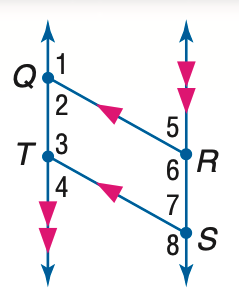Answer the mathemtical geometry problem and directly provide the correct option letter.
Question: In the figure, Q R \parallel T S, Q T \parallel R S, and m \angle 1 = 131. Find the measure of \angle 6.
Choices: A: 101 B: 111 C: 121 D: 131 D 